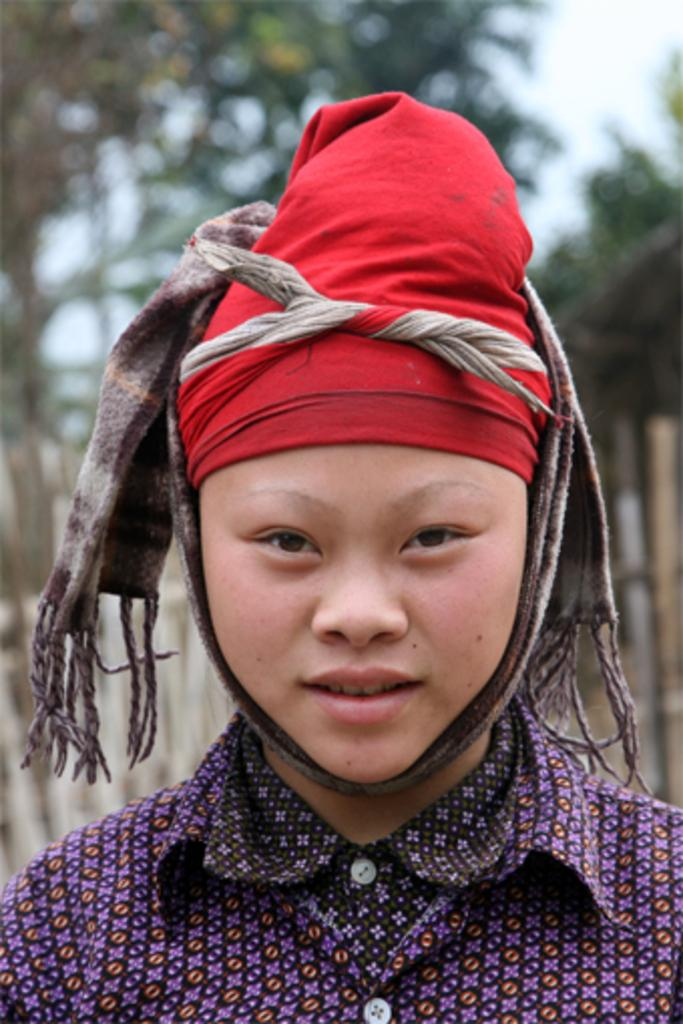Who is present in the image? There is a man in the image. What can be seen in the background of the image? There is sky and trees visible in the background of the image. Can you see an island in the image? No, there is no island present in the image. Is the man in the image walking on sand? There is no sand visible in the image, and the man's location is not specified. 